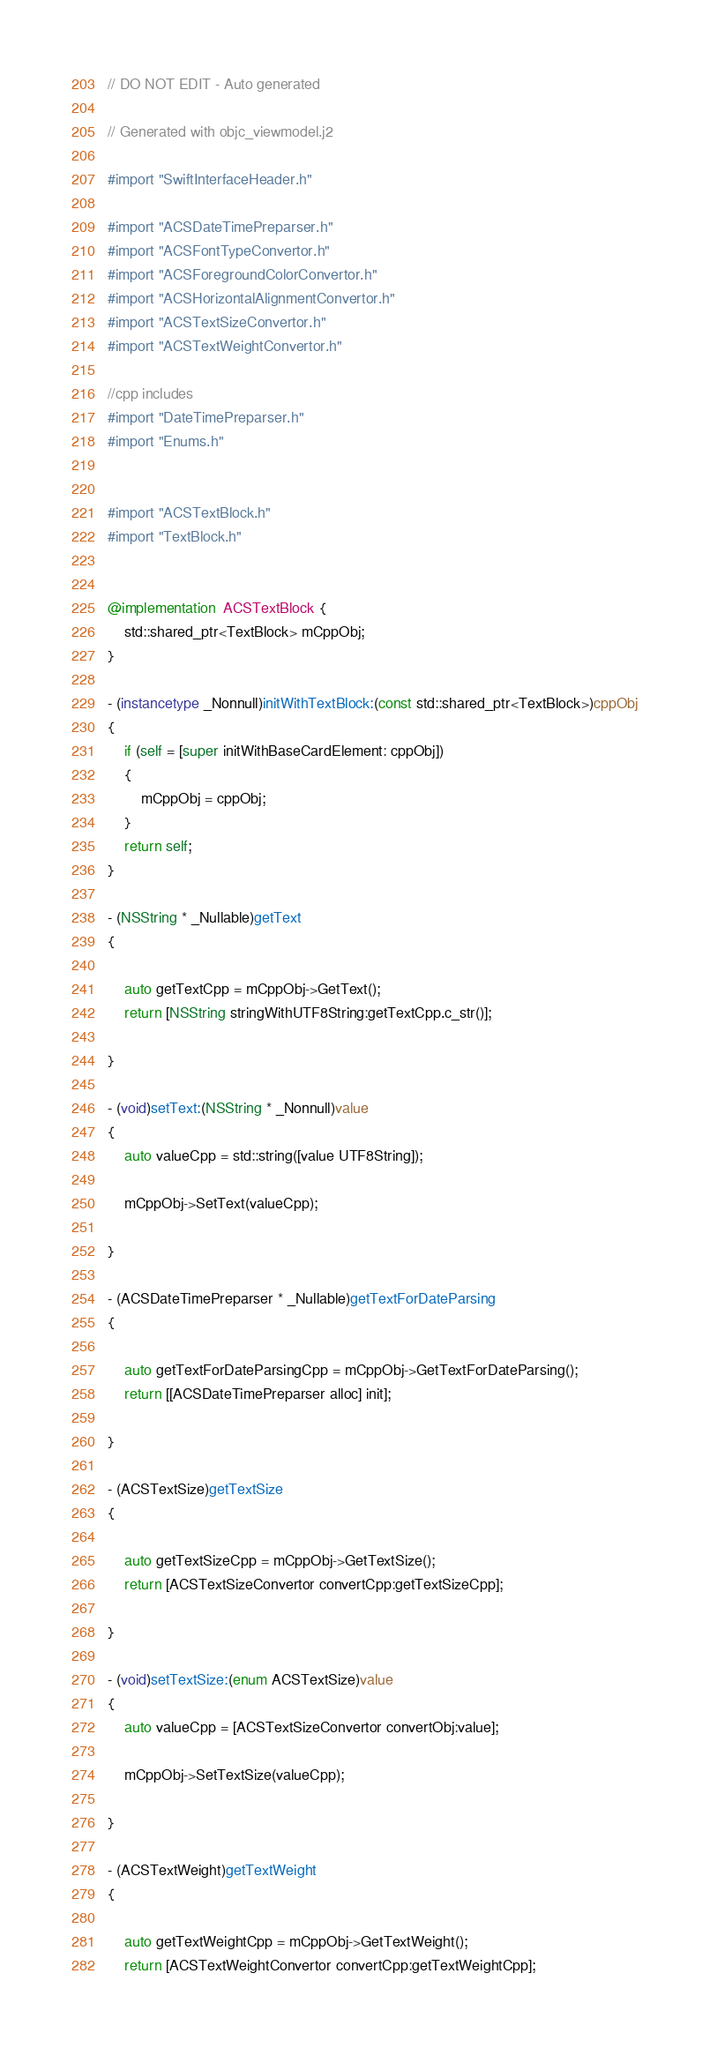<code> <loc_0><loc_0><loc_500><loc_500><_ObjectiveC_>// DO NOT EDIT - Auto generated

// Generated with objc_viewmodel.j2

#import "SwiftInterfaceHeader.h"

#import "ACSDateTimePreparser.h"
#import "ACSFontTypeConvertor.h"
#import "ACSForegroundColorConvertor.h"
#import "ACSHorizontalAlignmentConvertor.h"
#import "ACSTextSizeConvertor.h"
#import "ACSTextWeightConvertor.h"

//cpp includes
#import "DateTimePreparser.h"
#import "Enums.h"


#import "ACSTextBlock.h"
#import "TextBlock.h"


@implementation  ACSTextBlock {
    std::shared_ptr<TextBlock> mCppObj;
}

- (instancetype _Nonnull)initWithTextBlock:(const std::shared_ptr<TextBlock>)cppObj
{
    if (self = [super initWithBaseCardElement: cppObj])
    {
        mCppObj = cppObj;
    }
    return self;
}

- (NSString * _Nullable)getText
{
 
    auto getTextCpp = mCppObj->GetText();
    return [NSString stringWithUTF8String:getTextCpp.c_str()];

}

- (void)setText:(NSString * _Nonnull)value
{
    auto valueCpp = std::string([value UTF8String]);
 
    mCppObj->SetText(valueCpp);
    
}

- (ACSDateTimePreparser * _Nullable)getTextForDateParsing
{
 
    auto getTextForDateParsingCpp = mCppObj->GetTextForDateParsing();
    return [[ACSDateTimePreparser alloc] init];

}

- (ACSTextSize)getTextSize
{
 
    auto getTextSizeCpp = mCppObj->GetTextSize();
    return [ACSTextSizeConvertor convertCpp:getTextSizeCpp];

}

- (void)setTextSize:(enum ACSTextSize)value
{
    auto valueCpp = [ACSTextSizeConvertor convertObj:value];
 
    mCppObj->SetTextSize(valueCpp);
    
}

- (ACSTextWeight)getTextWeight
{
 
    auto getTextWeightCpp = mCppObj->GetTextWeight();
    return [ACSTextWeightConvertor convertCpp:getTextWeightCpp];
</code> 